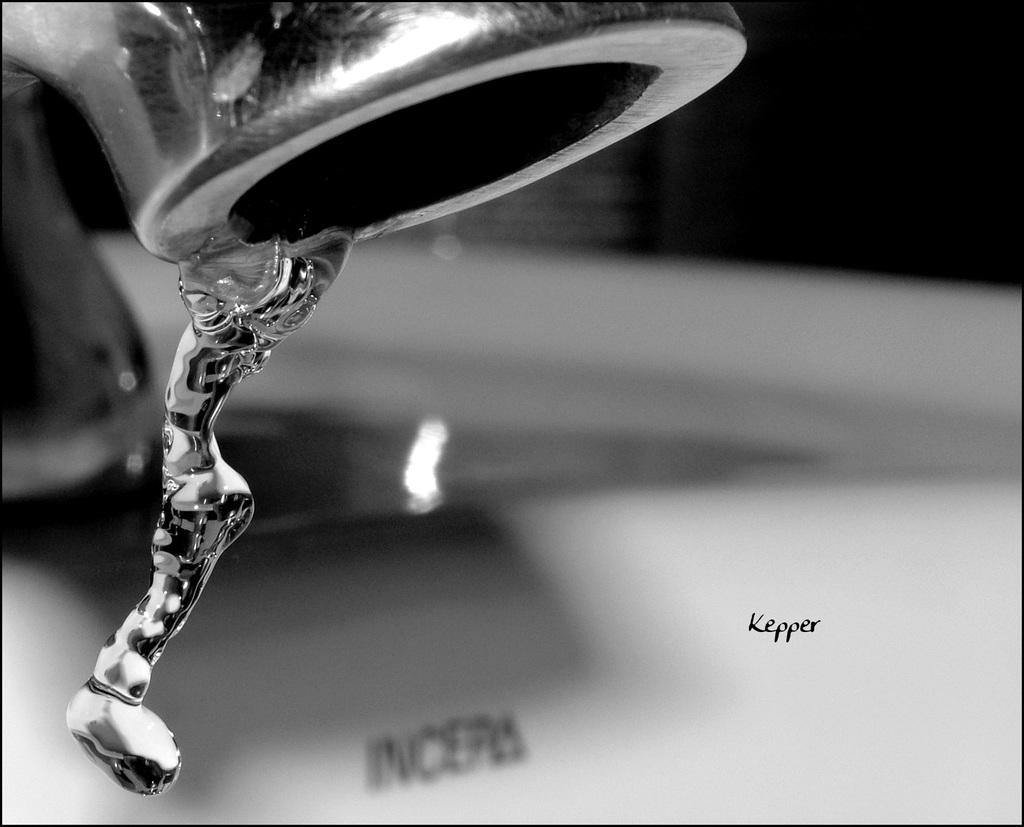What object in the image can be used to control the flow of water? There is a tap in the image that can be used to control the flow of water. What is the primary substance visible in the image? Water is visible in the image. What is located in the middle of the image? There is a watermark in the middle of the image. How would you describe the background of the image? The background of the image is blurred. How many trees can be seen in the image? There are no trees visible in the image. What type of event is taking place in the image? There is no event depicted in the image. Can you tell me how many bananas are on the tap in the image? There are no bananas present in the image. 